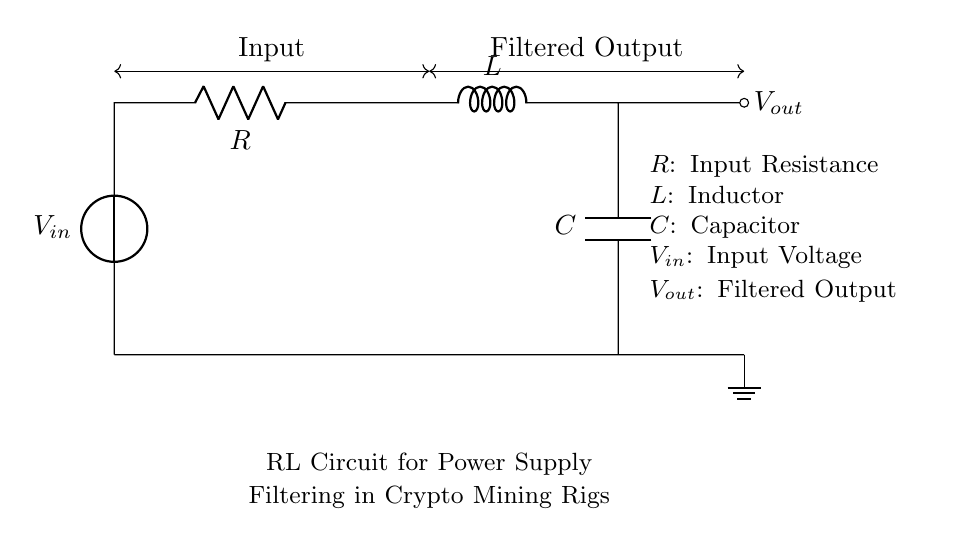What is the input voltage of this circuit? The input voltage is denoted as V_in in the circuit diagram, which is the voltage supplied to the circuit.
Answer: V_in What is the role of the inductor in this RL circuit? The inductor, labeled L, serves to oppose changes in current and helps in smoothing the output voltage by working with the resistor and capacitor to filter the input signal.
Answer: Smoothing What are the components present in this circuit? The components identified in the circuit include a resistor (R), an inductor (L), and a capacitor (C), along with the voltage source (V_in) and the filtered output (V_out).
Answer: Resistor, Inductor, Capacitor What type of filter does this RL circuit provide? This circuit functions as a low-pass filter, allowing low-frequency signals to pass while attenuating higher-frequency signals.
Answer: Low-pass filter What is the output voltage represented as in the circuit diagram? The output voltage is labeled as V_out, which is the voltage measured after passing through the filtering components of the circuit.
Answer: V_out How does the resistor affect the behavior of the circuit? The resistor (R) limits the current flow in the circuit, determining the time constant when combined with the inductor and affects the power dissipation in the circuit.
Answer: Limits current What would happen if the inductor value is increased? Increasing the inductor value (L) will increase the time constant of the circuit, leading to slower changes in current and a greater ability to filter out high-frequency noise from the power supply.
Answer: Slower response 